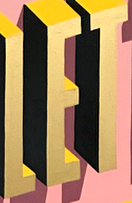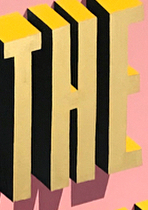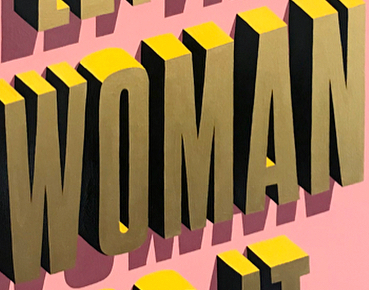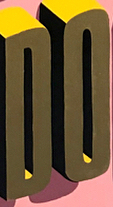What text appears in these images from left to right, separated by a semicolon? LET; THE; WOMAN; DO 